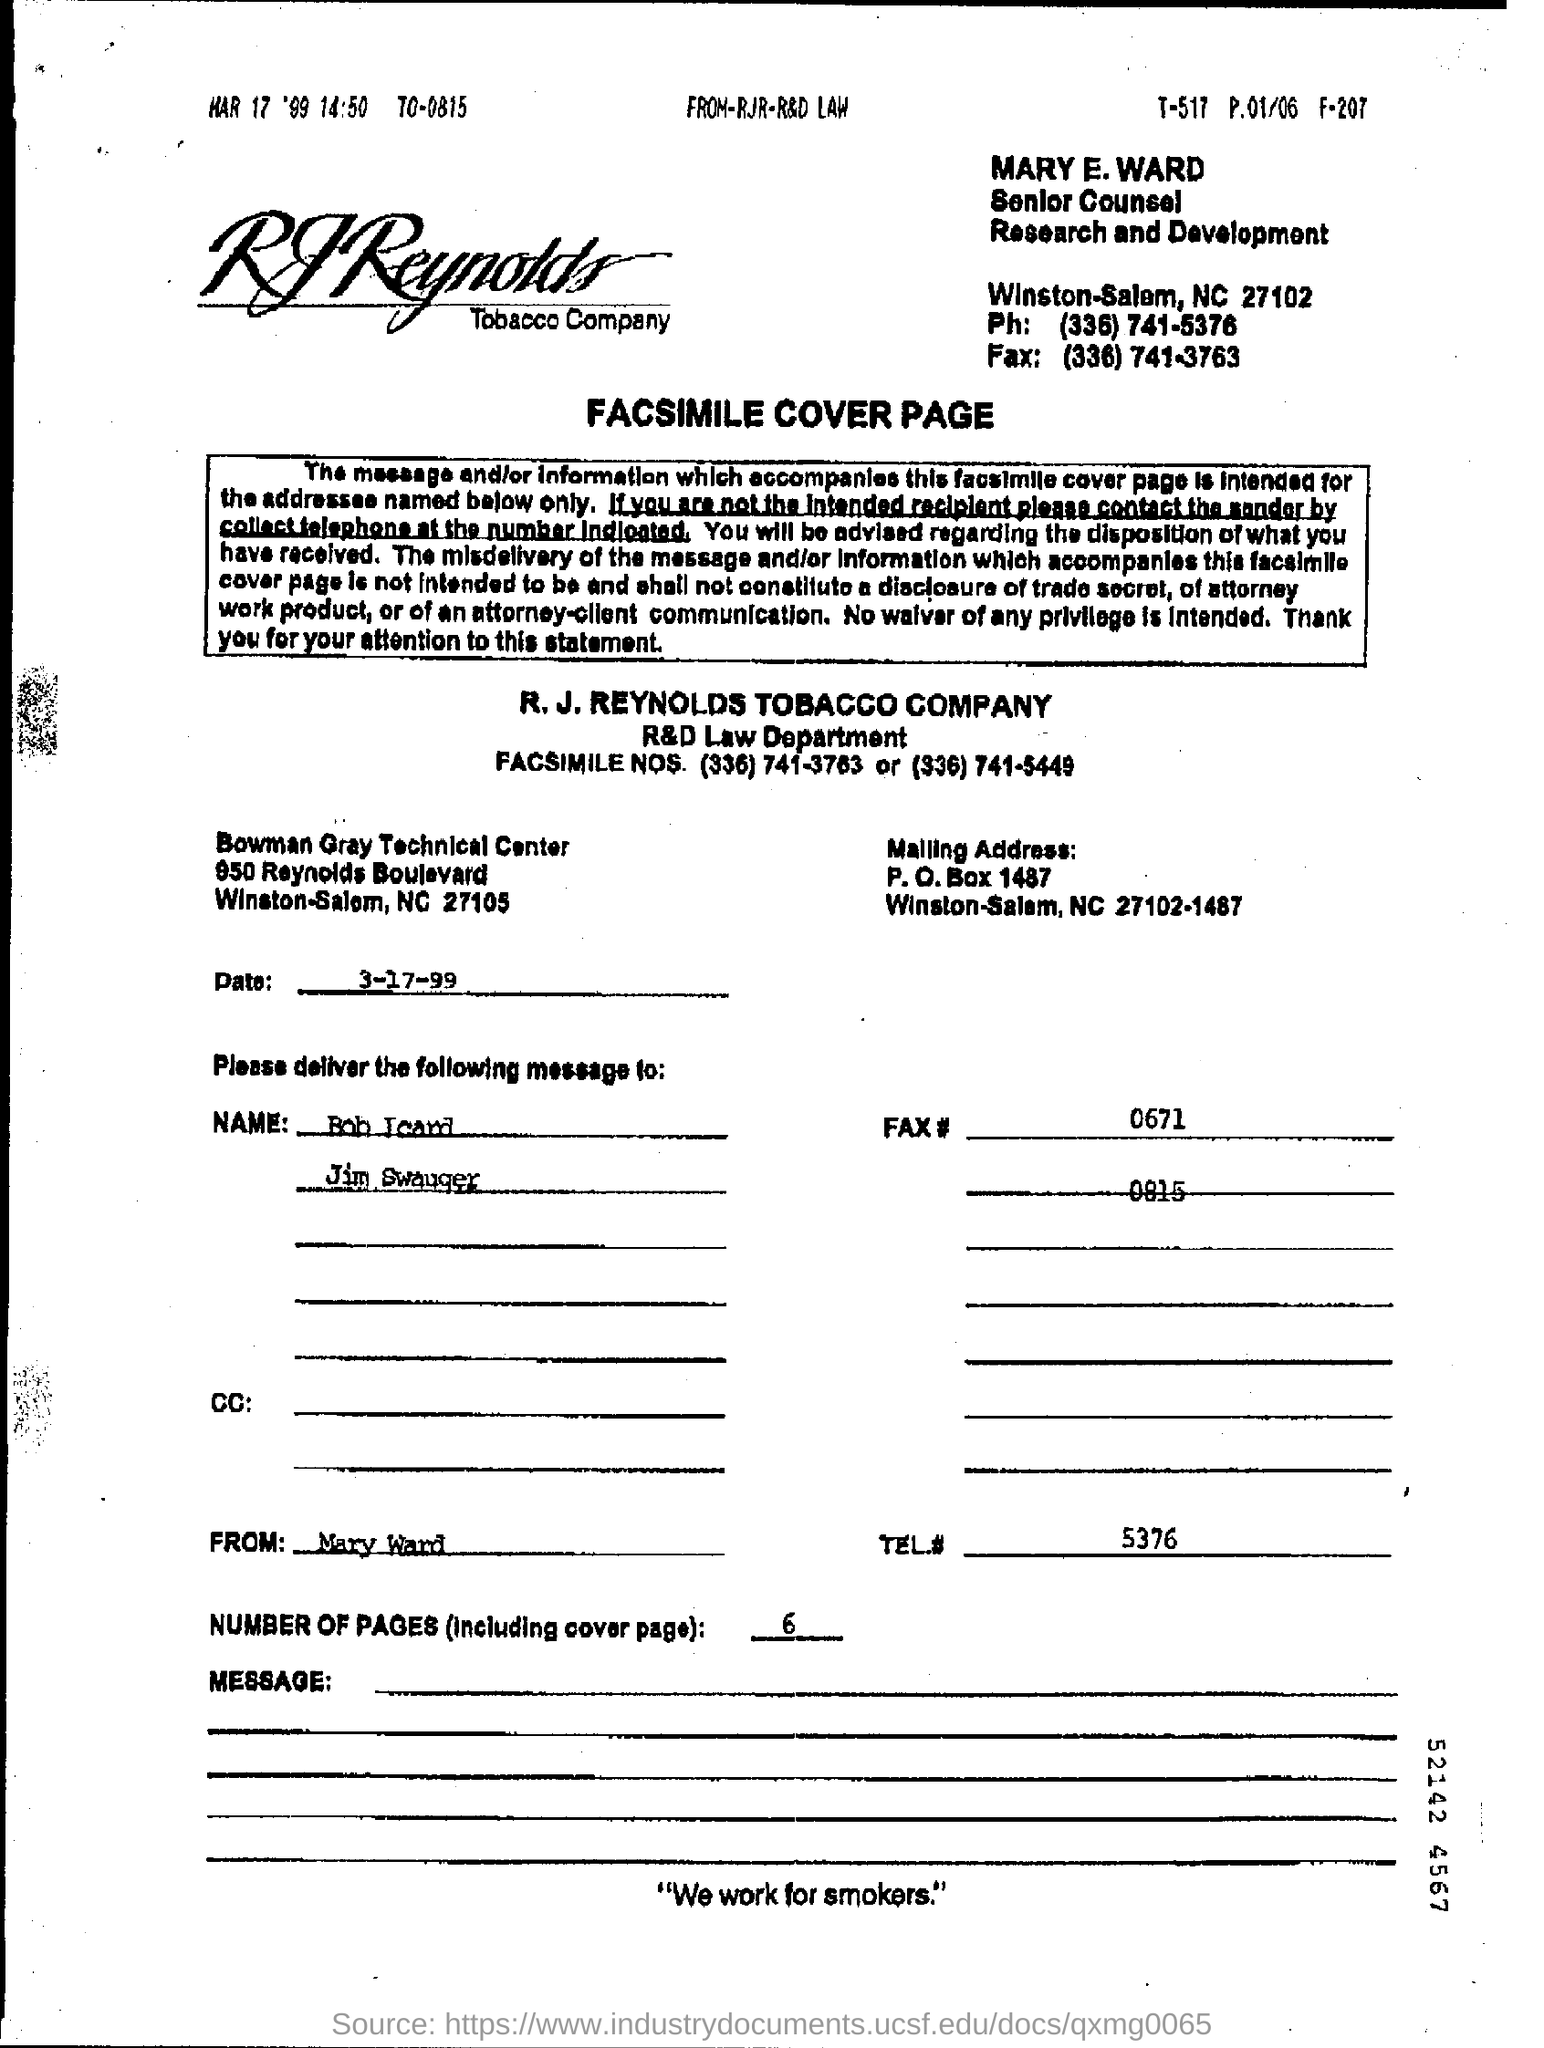Give some essential details in this illustration. Please provide your telephone number, which is 5376... followed by the area code and phone number. What is the date on the document? It is March 17, 1999. The number of pages, including the cover page, is six. 